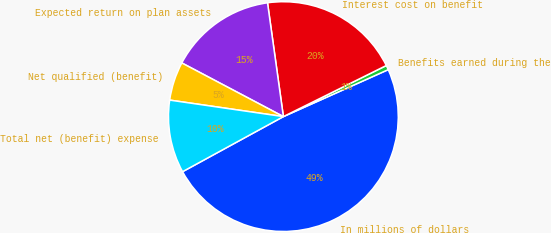Convert chart to OTSL. <chart><loc_0><loc_0><loc_500><loc_500><pie_chart><fcel>In millions of dollars<fcel>Benefits earned during the<fcel>Interest cost on benefit<fcel>Expected return on plan assets<fcel>Net qualified (benefit)<fcel>Total net (benefit) expense<nl><fcel>48.74%<fcel>0.63%<fcel>19.87%<fcel>15.06%<fcel>5.44%<fcel>10.25%<nl></chart> 